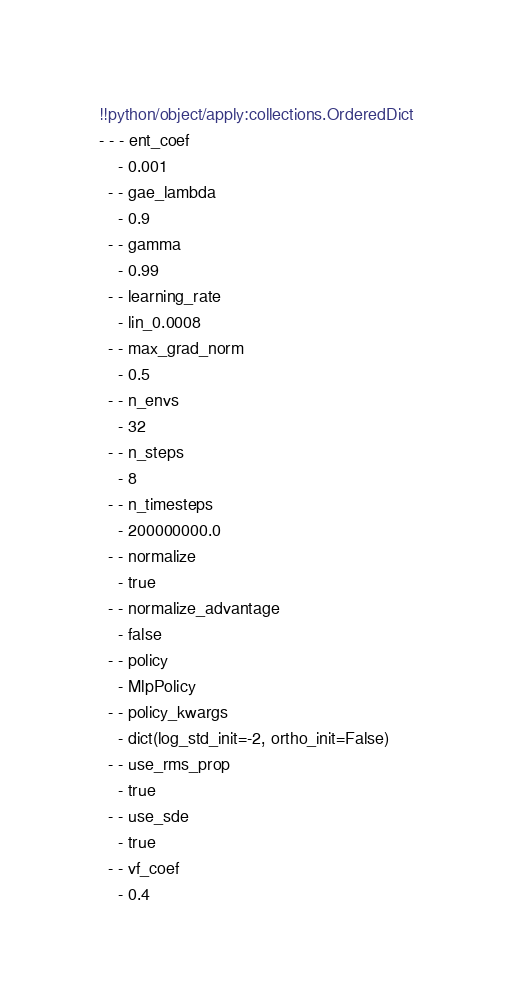<code> <loc_0><loc_0><loc_500><loc_500><_YAML_>!!python/object/apply:collections.OrderedDict
- - - ent_coef
    - 0.001
  - - gae_lambda
    - 0.9
  - - gamma
    - 0.99
  - - learning_rate
    - lin_0.0008
  - - max_grad_norm
    - 0.5
  - - n_envs
    - 32
  - - n_steps
    - 8
  - - n_timesteps
    - 200000000.0
  - - normalize
    - true
  - - normalize_advantage
    - false
  - - policy
    - MlpPolicy
  - - policy_kwargs
    - dict(log_std_init=-2, ortho_init=False)
  - - use_rms_prop
    - true
  - - use_sde
    - true
  - - vf_coef
    - 0.4
</code> 